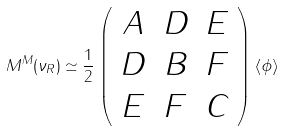Convert formula to latex. <formula><loc_0><loc_0><loc_500><loc_500>M ^ { M } ( \nu _ { R } ) \simeq \frac { 1 } { 2 } \left ( \begin{array} { c c c } A & D & E \\ D & B & F \\ E & F & C \end{array} \right ) \left \langle \phi \right \rangle</formula> 